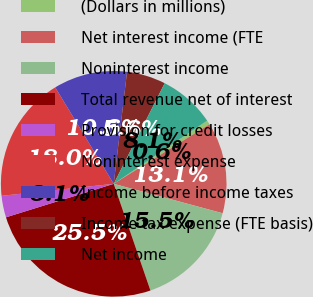Convert chart. <chart><loc_0><loc_0><loc_500><loc_500><pie_chart><fcel>(Dollars in millions)<fcel>Net interest income (FTE<fcel>Noninterest income<fcel>Total revenue net of interest<fcel>Provision for credit losses<fcel>Noninterest expense<fcel>Income before income taxes<fcel>Income tax expense (FTE basis)<fcel>Net income<nl><fcel>0.61%<fcel>13.05%<fcel>15.53%<fcel>25.48%<fcel>3.1%<fcel>18.02%<fcel>10.56%<fcel>5.58%<fcel>8.07%<nl></chart> 